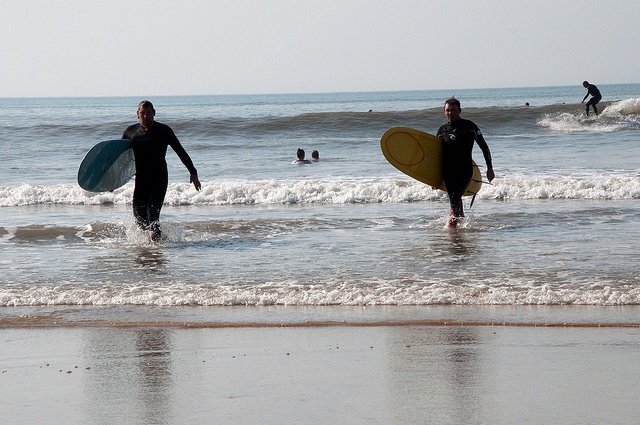Describe the objects in this image and their specific colors. I can see people in lightgray, black, gray, darkgray, and maroon tones, people in lightgray, black, gray, and darkgray tones, surfboard in lightgray, maroon, black, olive, and gray tones, surfboard in lightgray, black, gray, purple, and darkblue tones, and people in lightgray, black, gray, darkgray, and navy tones in this image. 